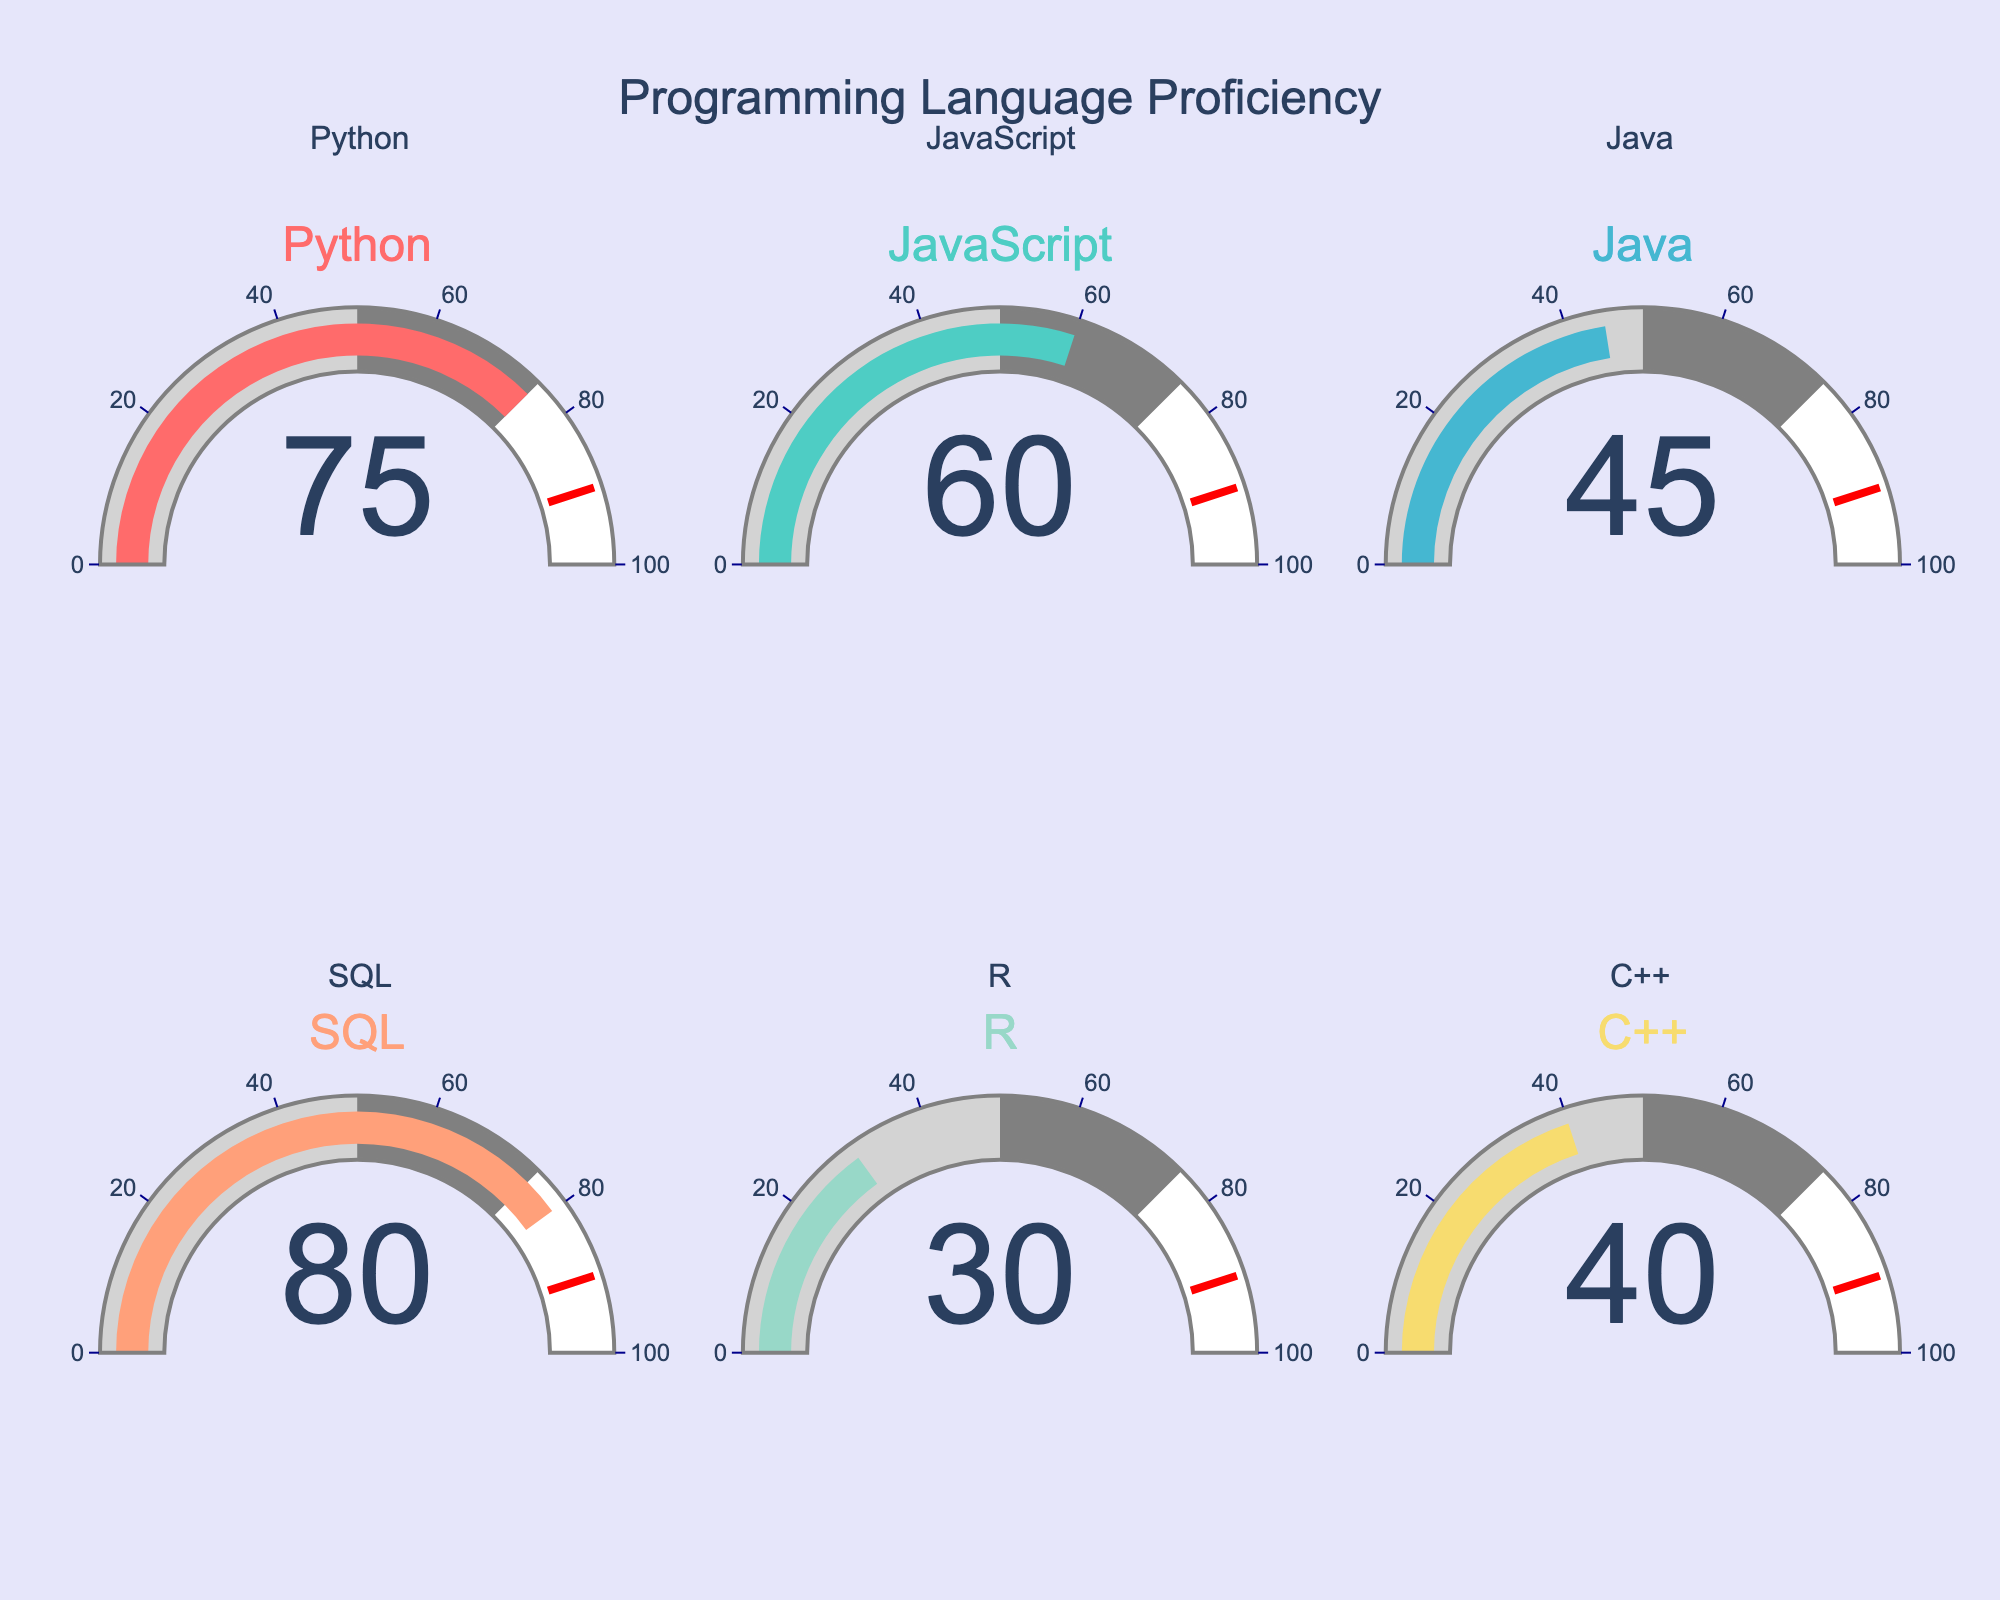What's the highest proficiency level shown for any programming language? The highest proficiency level can be found by identifying the gauge with the largest percentage value. From the data, SQL has the highest proficiency level at 80%.
Answer: 80% Which programming language has the lowest proficiency level? To find the programming language with the lowest proficiency level, look for the gauge with the smallest percentage value. According to the data, R has the lowest proficiency level at 30%.
Answer: R Calculate the average proficiency level across all programming languages. Add up all the proficiency levels and divide by the number of programming languages: (75 + 60 + 45 + 80 + 30 + 40) / 6 = 330 / 6 = 55%
Answer: 55% What is the proficiency level difference between Python and Java? Subtract the proficiency level of Java from that of Python: 75% - 45% = 30%.
Answer: 30% Is JavaScript's proficiency level greater than that of Java? Compare the proficiency levels: JavaScript's proficiency level is 60% and Java's is 45%. Since 60% is greater than 45%, JavaScript's proficiency level is greater than Java's.
Answer: Yes What is the median proficiency level of these programming languages? First, order the proficiency levels from smallest to largest: 30, 40, 45, 60, 75, 80. With 6 values, the median is the average of the 3rd and 4th values: (45 + 60) / 2 = 52.5%
Answer: 52.5% Which programming languages have proficiency levels above the overall average? First, calculate the average proficiency level, which is 55%. Then, identify the programming languages with levels above this value: Python (75%), JavaScript (60%), and SQL (80%).
Answer: Python, JavaScript, SQL What is the total proficiency level for C++ and R combined? Add the proficiency levels of C++ and R: 40% + 30% = 70%
Answer: 70% Are there more programming languages with proficiency levels above or below 50%? Count the number of languages above 50% (Python, JavaScript, SQL: 3) and below 50% (Java, R, C++: 3). Since both counts are equal, there are the same number of languages above and below 50%.
Answer: Equal How much higher is SQL's proficiency level compared to C++? Subtract the proficiency level of C++ from SQL: 80% - 40% = 40%.
Answer: 40% 